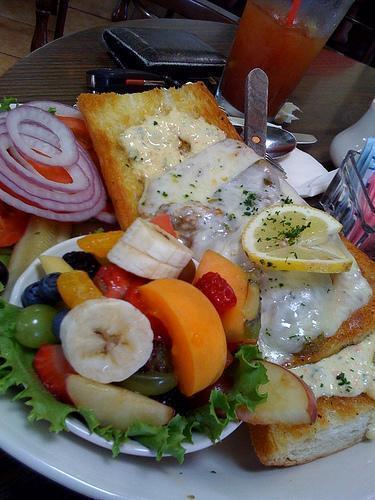What color are the onions on the top left part of the white plate?
Choose the right answer from the provided options to respond to the question.
Options: Sweet, yellow, white, purple. Purple. 